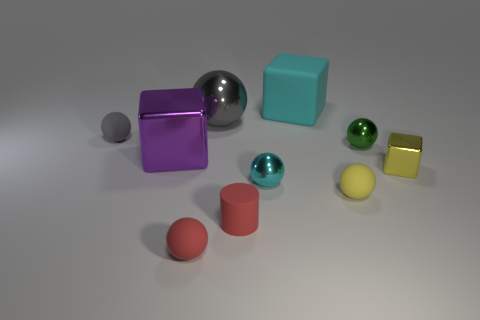How big is the cyan thing that is in front of the big matte cube right of the cyan thing in front of the yellow shiny block?
Give a very brief answer. Small. There is a small metal object that is left of the cyan matte cube; does it have the same color as the large rubber cube?
Your answer should be compact. Yes. The other metallic thing that is the same shape as the tiny yellow shiny object is what size?
Your answer should be very brief. Large. What number of things are either tiny objects that are to the left of the large purple object or red objects to the left of the red cylinder?
Your answer should be compact. 2. There is a small matte thing behind the small rubber sphere that is on the right side of the small cyan shiny thing; what shape is it?
Provide a succinct answer. Sphere. Are there any other things that are the same color as the big shiny block?
Your answer should be very brief. No. What number of things are either small green balls or tiny rubber cylinders?
Keep it short and to the point. 2. Are there any balls that have the same size as the cyan matte block?
Ensure brevity in your answer.  Yes. What is the shape of the small cyan shiny thing?
Offer a very short reply. Sphere. Are there more tiny gray things behind the small red rubber sphere than small red balls behind the small gray sphere?
Your answer should be compact. Yes. 